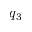<formula> <loc_0><loc_0><loc_500><loc_500>q _ { 3 }</formula> 